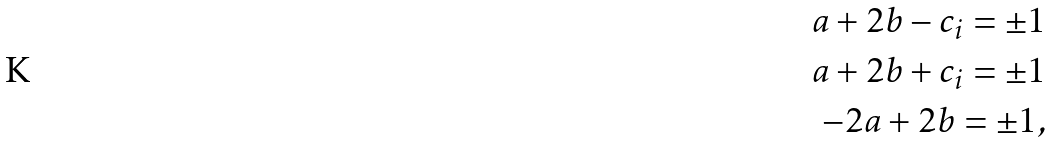<formula> <loc_0><loc_0><loc_500><loc_500>a + 2 b - c _ { i } = \pm 1 \\ a + 2 b + c _ { i } = \pm 1 \\ - 2 a + 2 b = \pm 1 ,</formula> 